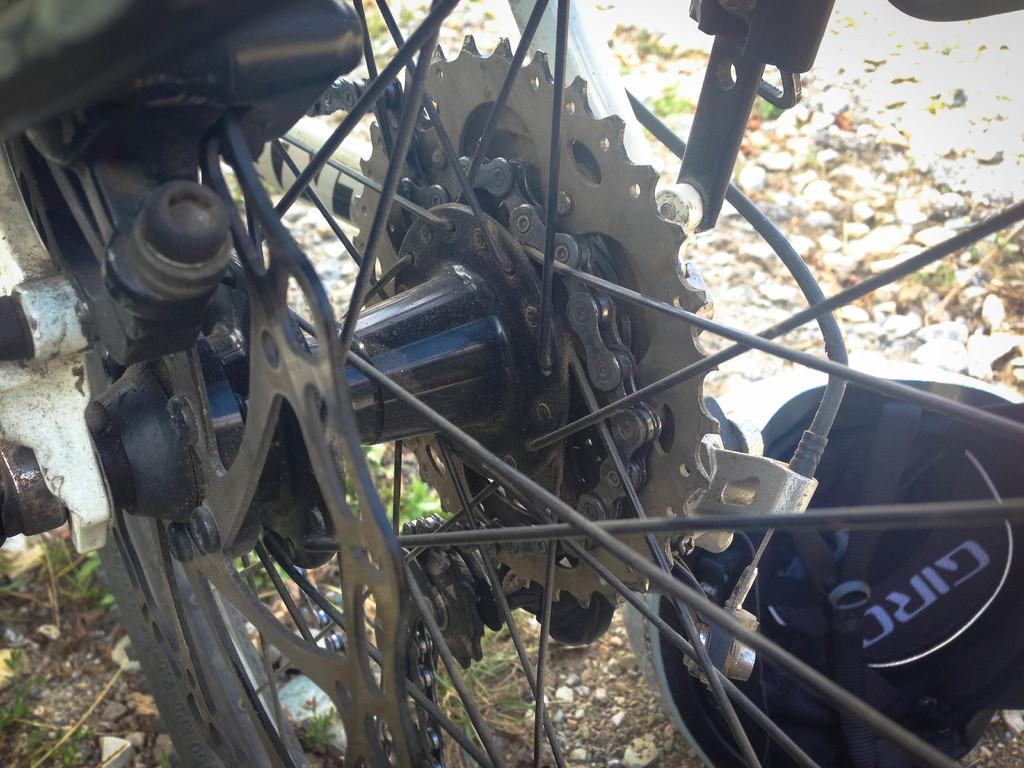What is the main object in the image? There is a wheel with a chain in the image. What other types of objects are present in the image? There are other metal objects in the image. Can you describe the helmet in the image? There is a helmet on the ground in the image. What country is the sheep from in the image? There is no sheep present in the image. How does the self-awareness of the objects in the image affect their appearance? The objects in the image do not have self-awareness, as they are inanimate objects. 